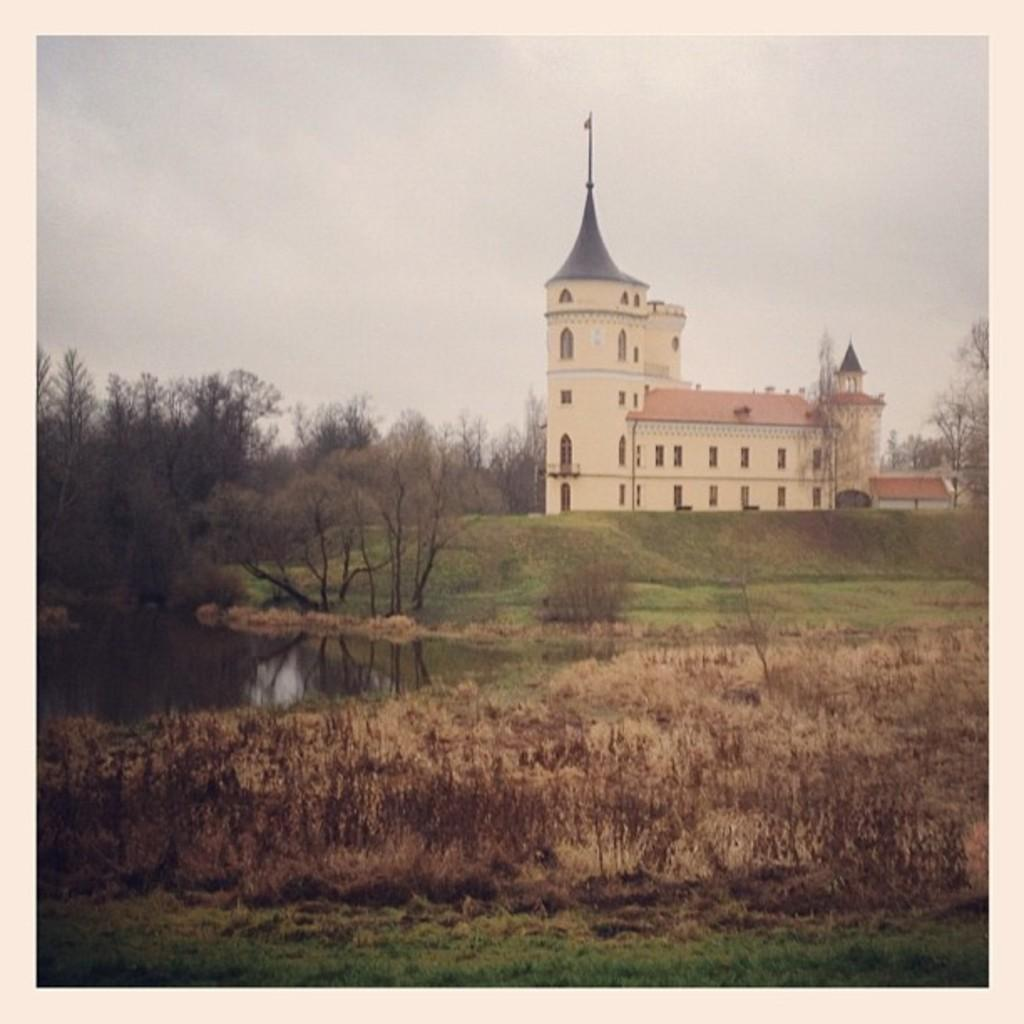What type of living organisms can be seen in the image? Plants and trees are visible in the image. What can be seen in the water in the image? The image does not show anything specific in the water. What is the closest vegetation to the viewer in the image? There are trees in the foreground of the image. What type of structures can be seen in the background of the image? There are buildings in the background of the image. What is the condition of the sky in the image? The sky is cloudy in the background of the image. Who is the owner of the regret expressed in the image? There is no regret expressed in the image, nor is there any indication of an owner. 